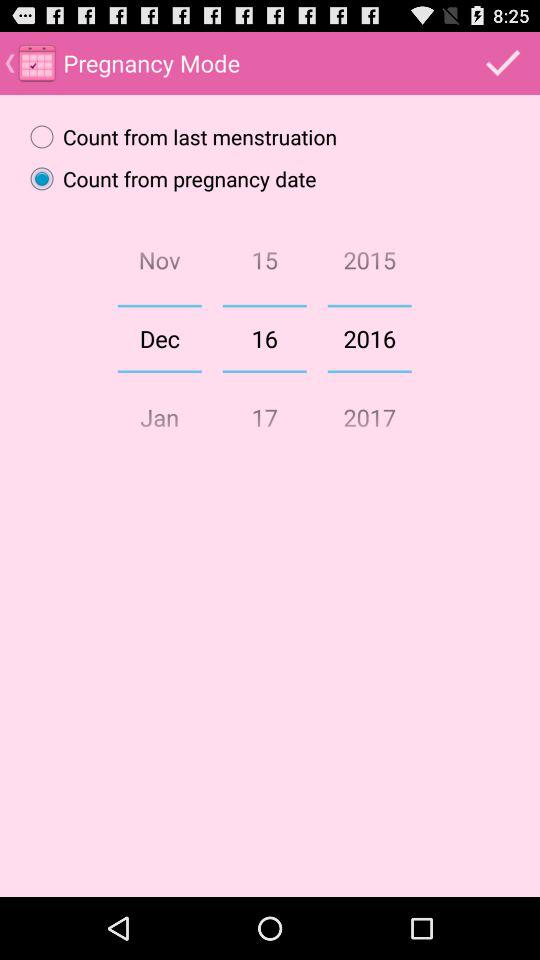What is the selected date? The selected date is December 16, 2016. 